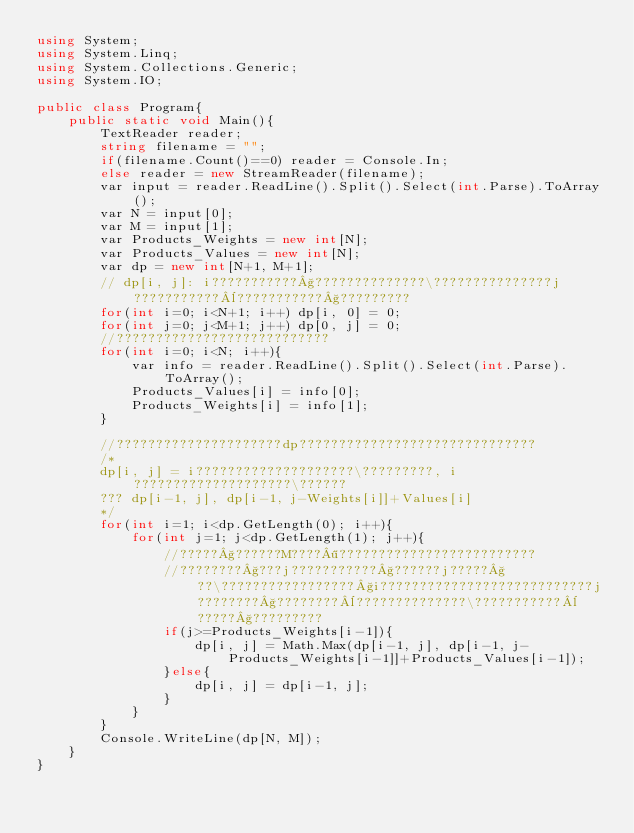<code> <loc_0><loc_0><loc_500><loc_500><_C#_>using System;
using System.Linq;
using System.Collections.Generic;
using System.IO;

public class Program{
    public static void Main(){
        TextReader reader;
        string filename = "";
        if(filename.Count()==0) reader = Console.In;
        else reader = new StreamReader(filename);
        var input = reader.ReadLine().Split().Select(int.Parse).ToArray();
        var N = input[0];
        var M = input[1];
        var Products_Weights = new int[N];
        var Products_Values = new int[N];
        var dp = new int[N+1, M+1];
        // dp[i, j]: i???????????§??????????????\???????????????j???????????¨???????????§?????????
        for(int i=0; i<N+1; i++) dp[i, 0] = 0;
        for(int j=0; j<M+1; j++) dp[0, j] = 0;
        //???????????????????????????
        for(int i=0; i<N; i++){
            var info = reader.ReadLine().Split().Select(int.Parse).ToArray();
            Products_Values[i] = info[0];
            Products_Weights[i] = info[1];
        }

        //?????????????????????dp??????????????????????????????
        /*
        dp[i, j] = i????????????????????\?????????, i????????????????????\??????
        ??? dp[i-1, j], dp[i-1, j-Weights[i]]+Values[i]
        */
        for(int i=1; i<dp.GetLength(0); i++){
            for(int j=1; j<dp.GetLength(1); j++){
                //?????§??????M????¶?????????????????????????
                //????????§???j???????????§??????j?????§??\?????????????????§i???????????????????????????j????????§????????¨??????????????\???????????¨?????§?????????
                if(j>=Products_Weights[i-1]){
                    dp[i, j] = Math.Max(dp[i-1, j], dp[i-1, j-Products_Weights[i-1]]+Products_Values[i-1]);
                }else{
                    dp[i, j] = dp[i-1, j];
                }
            }
        }
        Console.WriteLine(dp[N, M]);
    }
}</code> 